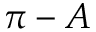<formula> <loc_0><loc_0><loc_500><loc_500>{ \pi } - A</formula> 